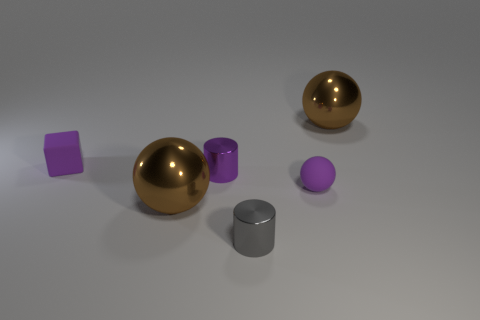Add 1 small gray objects. How many objects exist? 7 Subtract all cubes. How many objects are left? 5 Add 3 big green matte balls. How many big green matte balls exist? 3 Subtract 1 purple cylinders. How many objects are left? 5 Subtract all matte blocks. Subtract all cylinders. How many objects are left? 3 Add 3 gray metallic cylinders. How many gray metallic cylinders are left? 4 